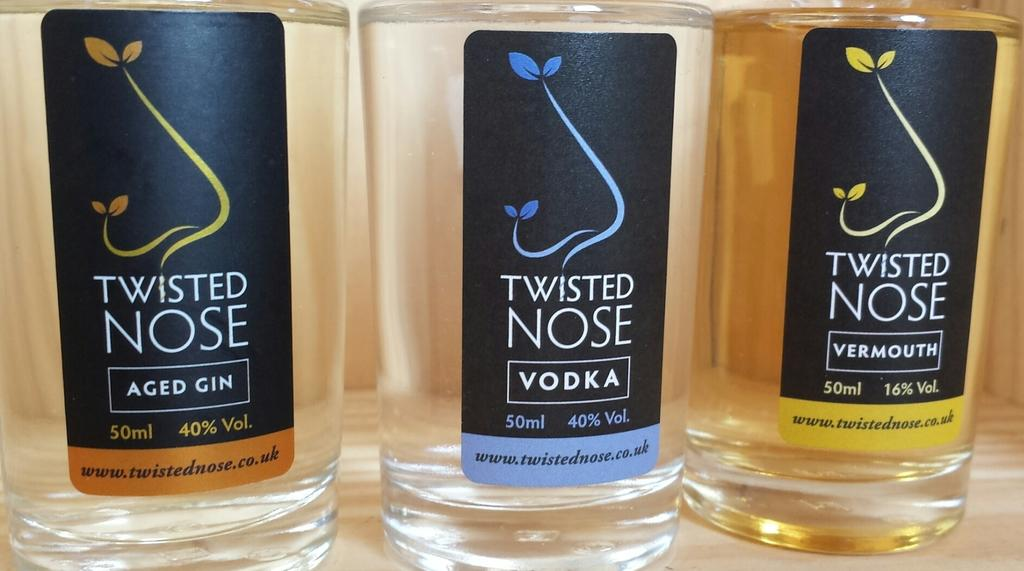<image>
Present a compact description of the photo's key features. Three different bottles of spirits by Twisted Nose. 